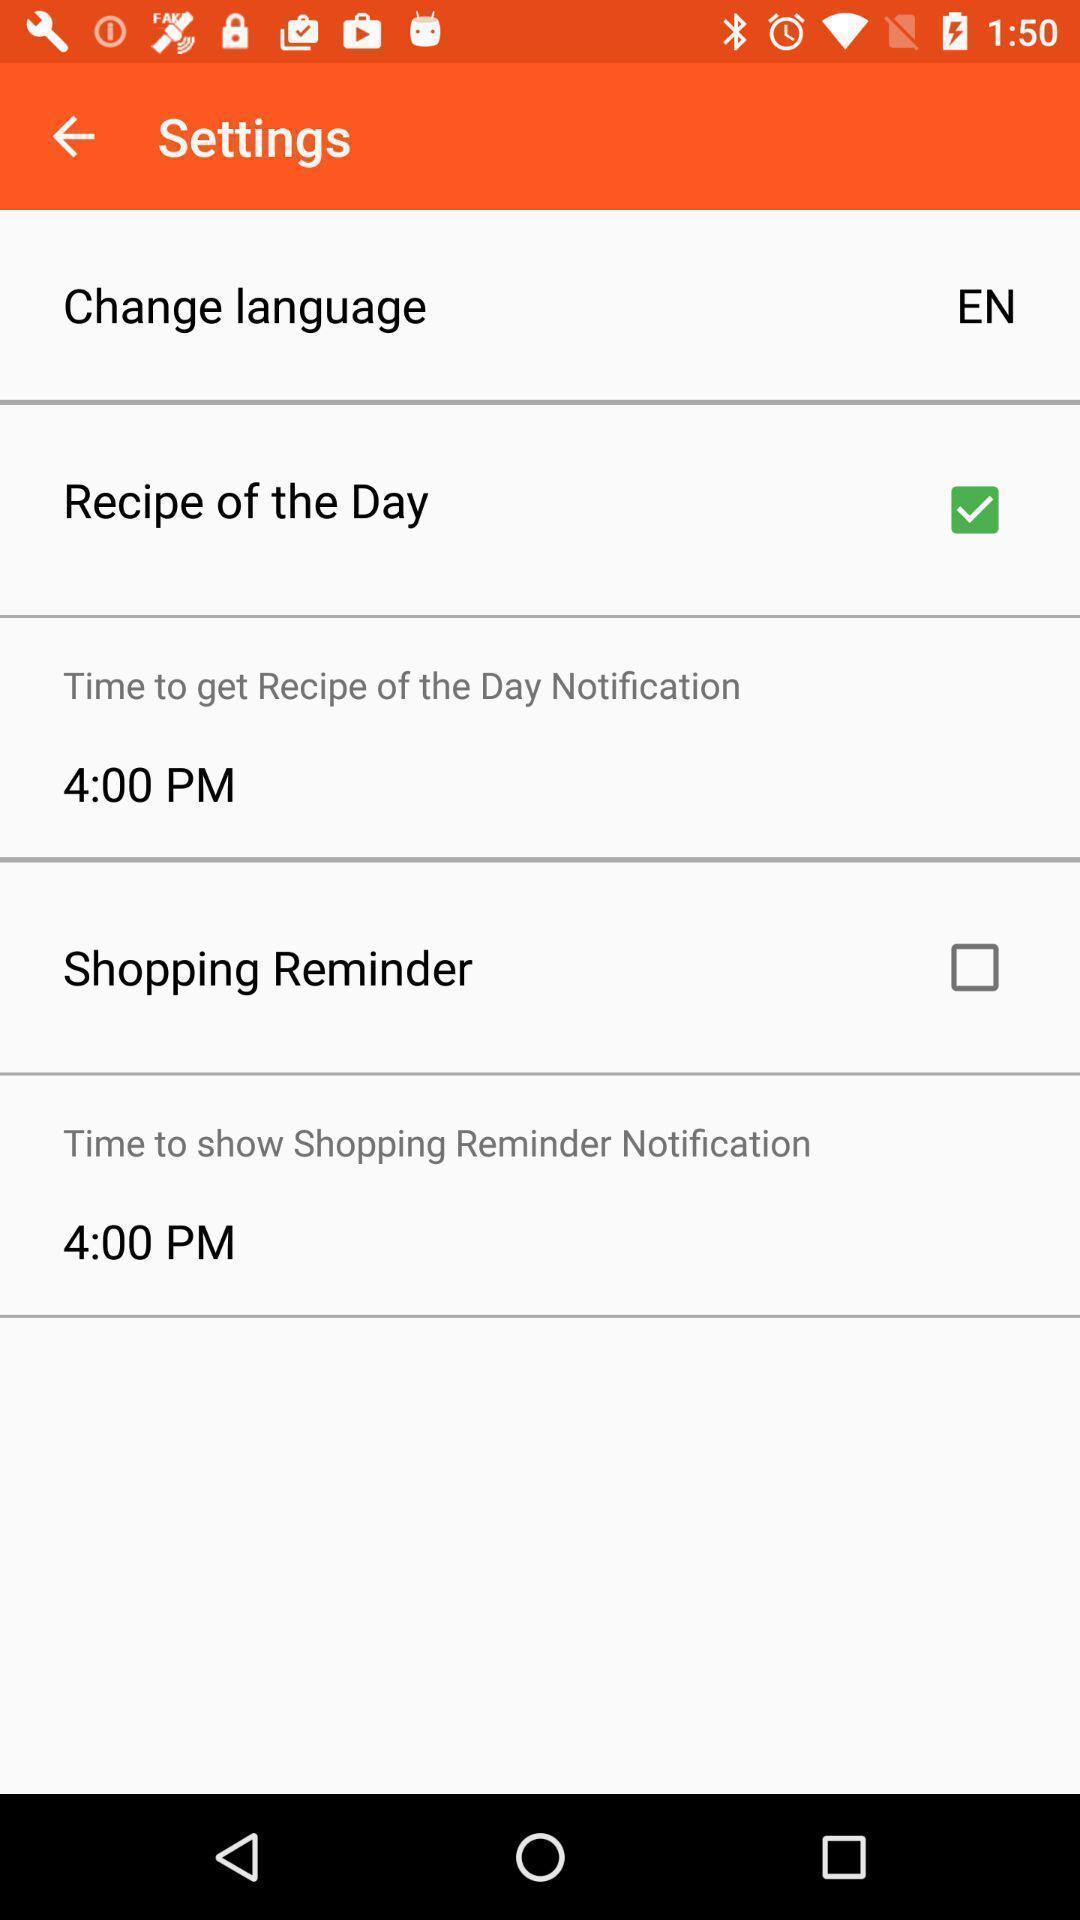Provide a description of this screenshot. Settings page. 